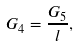Convert formula to latex. <formula><loc_0><loc_0><loc_500><loc_500>G _ { 4 } = \frac { G _ { 5 } } l ,</formula> 